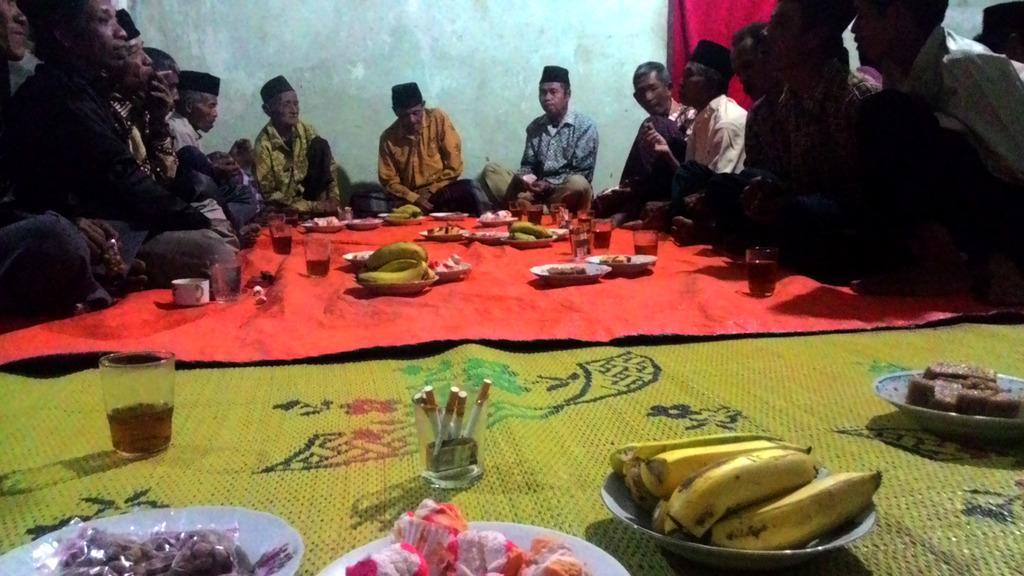In one or two sentences, can you explain what this image depicts? In this image I can see the group of people sitting and these people are wearing the different color dresses and also caps. In-front of these people I can see the plates with food and the glasses with drink. And these are on the red and green color sheets. 